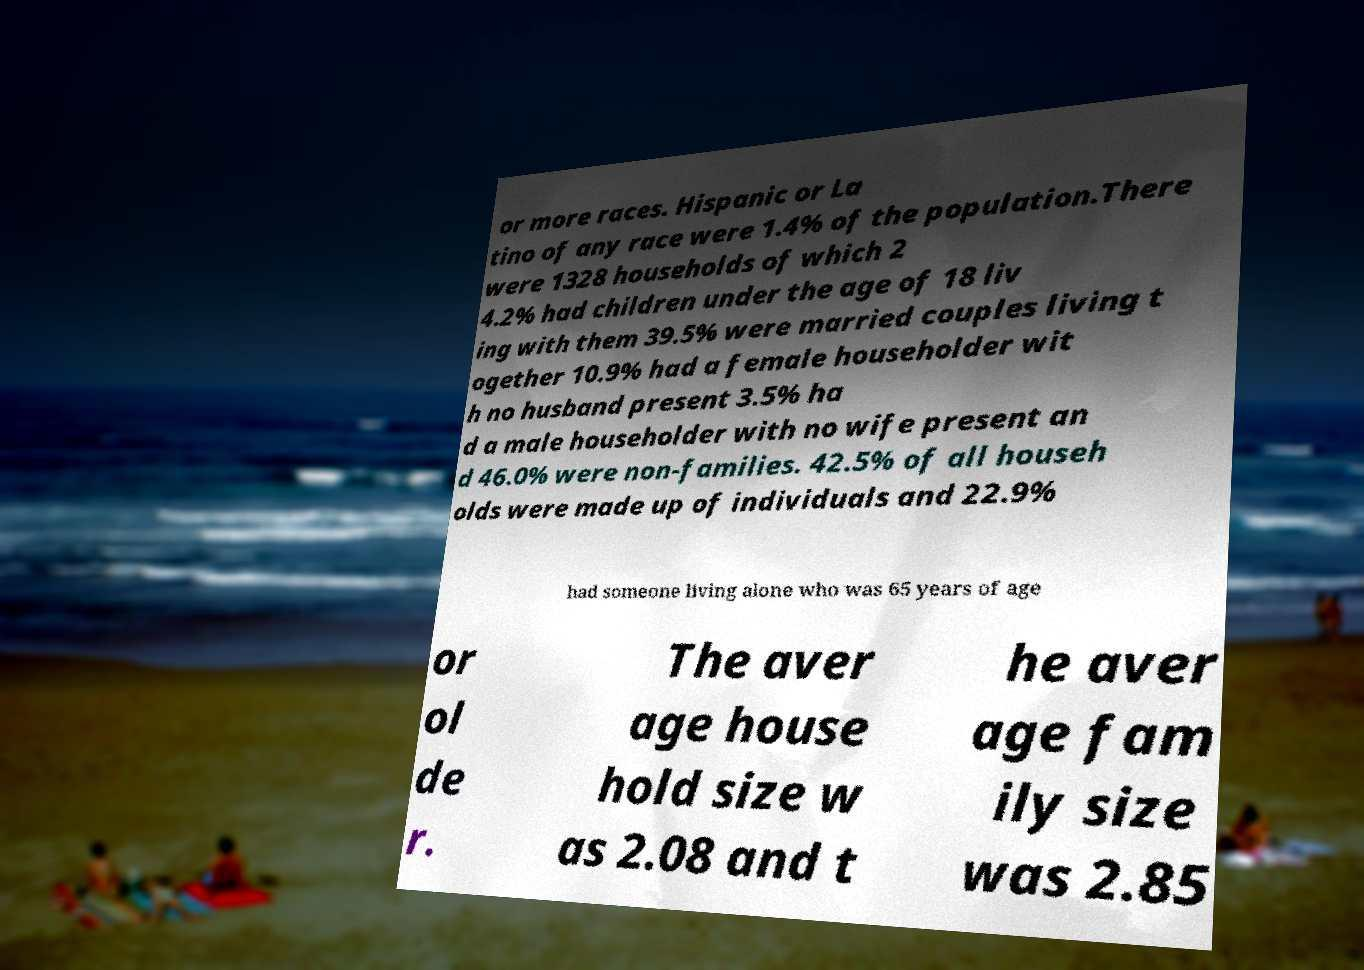What messages or text are displayed in this image? I need them in a readable, typed format. or more races. Hispanic or La tino of any race were 1.4% of the population.There were 1328 households of which 2 4.2% had children under the age of 18 liv ing with them 39.5% were married couples living t ogether 10.9% had a female householder wit h no husband present 3.5% ha d a male householder with no wife present an d 46.0% were non-families. 42.5% of all househ olds were made up of individuals and 22.9% had someone living alone who was 65 years of age or ol de r. The aver age house hold size w as 2.08 and t he aver age fam ily size was 2.85 